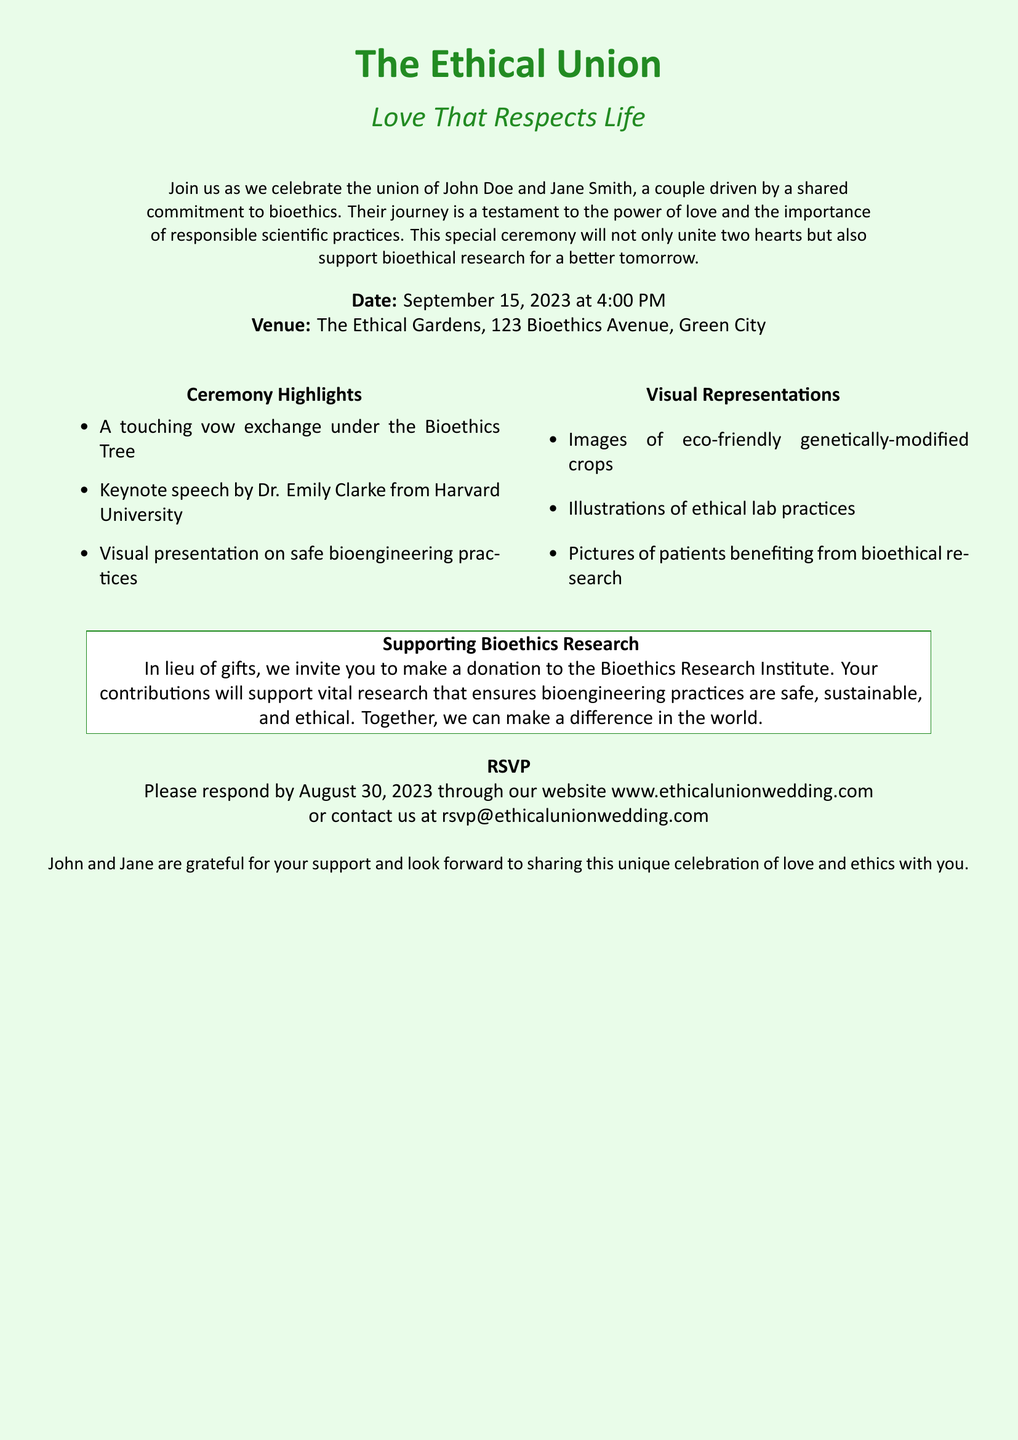What is the name of the couple getting married? The document specifies that the couple getting married is John Doe and Jane Smith.
Answer: John Doe and Jane Smith What is the date of the wedding? The document states that the wedding will take place on September 15, 2023.
Answer: September 15, 2023 Where is the venue located? The wedding venue is mentioned as The Ethical Gardens, 123 Bioethics Avenue, Green City.
Answer: The Ethical Gardens, 123 Bioethics Avenue, Green City Who is giving a keynote speech at the ceremony? The document mentions that Dr. Emily Clarke from Harvard University will give a keynote speech at the ceremony.
Answer: Dr. Emily Clarke What is the focus of the visual presentation during the ceremony? The document states that the visual presentation will cover safe bioengineering practices.
Answer: Safe bioengineering practices In what way can guests contribute to bioethics research? The invitation encourages guests to make a donation to the Bioethics Research Institute instead of gifts.
Answer: Donation to the Bioethics Research Institute What will happen under the Bioethics Tree? The document indicates that there will be a touching vow exchange under the Bioethics Tree.
Answer: Vow exchange By when should guests RSVP? The invitation specifies that guests should respond by August 30, 2023.
Answer: August 30, 2023 What is the theme of the wedding celebration? The document highlights that the theme is "Love That Respects Life."
Answer: Love That Respects Life 